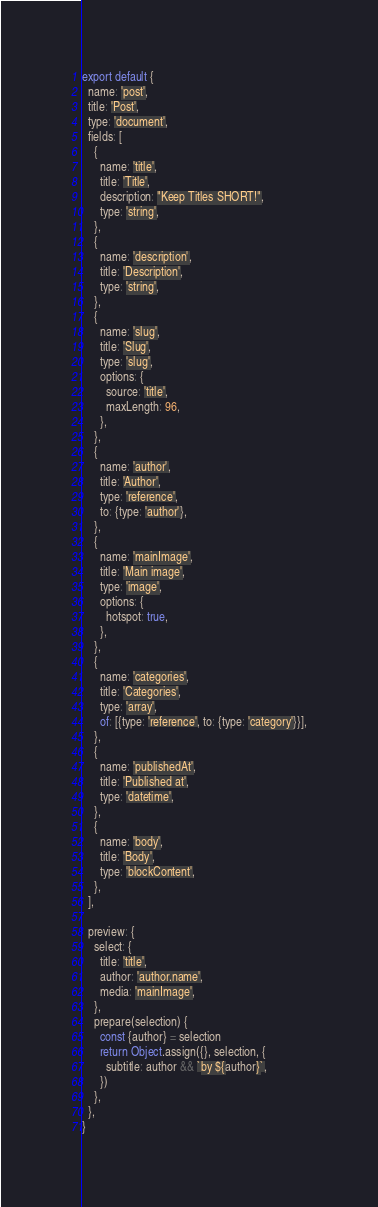Convert code to text. <code><loc_0><loc_0><loc_500><loc_500><_JavaScript_>export default {
  name: 'post',
  title: 'Post',
  type: 'document',
  fields: [
    {
      name: 'title',
      title: 'Title',
      description: "Keep Titles SHORT!",
      type: 'string',
    },
    {
      name: 'description',
      title: 'Description',
      type: 'string',
    },
    {
      name: 'slug',
      title: 'Slug',
      type: 'slug',
      options: {
        source: 'title',
        maxLength: 96,
      },
    },
    {
      name: 'author',
      title: 'Author',
      type: 'reference',
      to: {type: 'author'},
    },
    {
      name: 'mainImage',
      title: 'Main image',
      type: 'image',
      options: {
        hotspot: true,
      },
    },
    {
      name: 'categories',
      title: 'Categories',
      type: 'array',
      of: [{type: 'reference', to: {type: 'category'}}],
    },
    {
      name: 'publishedAt',
      title: 'Published at',
      type: 'datetime',
    },
    {
      name: 'body',
      title: 'Body',
      type: 'blockContent',
    },
  ],

  preview: {
    select: {
      title: 'title',
      author: 'author.name',
      media: 'mainImage',
    },
    prepare(selection) {
      const {author} = selection
      return Object.assign({}, selection, {
        subtitle: author && `by ${author}`,
      })
    },
  },
}
</code> 